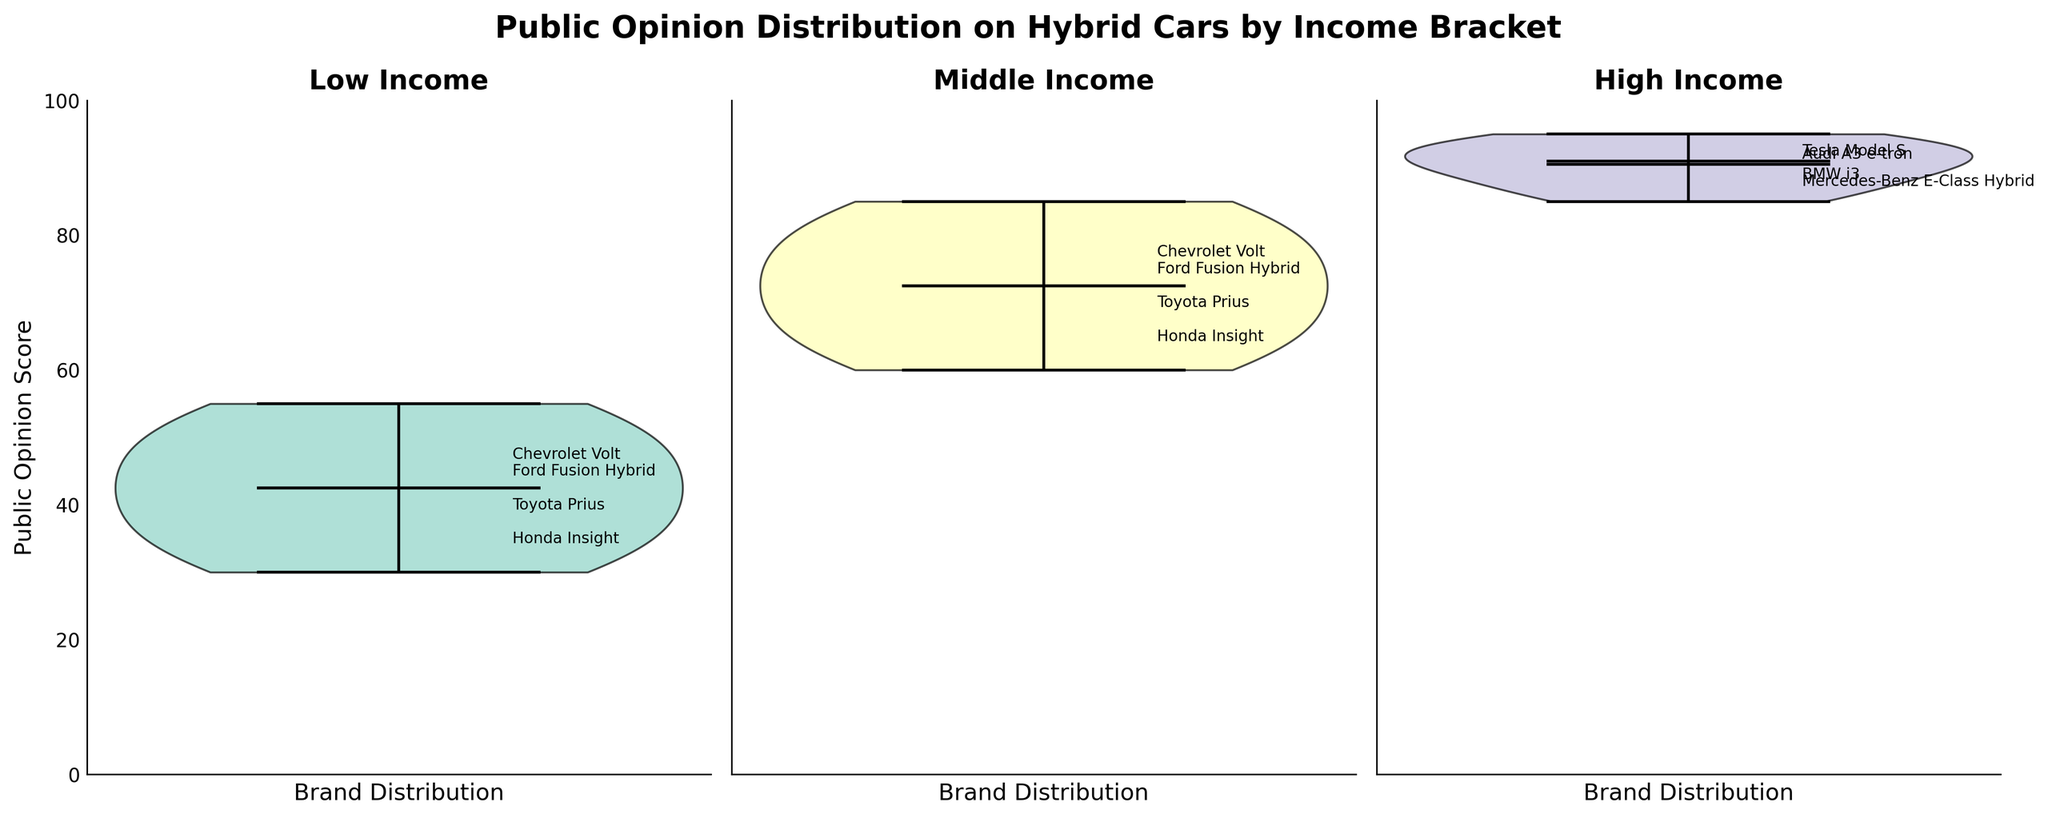What is the title of the figure? The title of the figure is typically found at the top center and succinctly describes the subject of the figure.
Answer: Public Opinion Distribution on Hybrid Cars by Income Bracket How many income brackets are represented in the figure? There are three subplots, each representing a different income bracket.
Answer: Three What is the y-axis label in the figure? The y-axis label provides information about what the y-values represent.
Answer: Public Opinion Score What is the median public opinion score for the low income bracket? The median is the value separating the higher half from the lower half of the data points. It is shown as a horizontal line inside the violin plot.
Answer: 42.5 What is the average public opinion score for the high income bracket? To find the average, sum all the public opinion scores in the high income bracket and divide by the number of data points in that bracket. The scores are 90, 85, 88, 92, 95, and 93. Their sum is 543, and there are six data points, so the average is 543/6 = 90.5.
Answer: 90.5 Which income bracket has the highest mean public opinion score? The mean is shown as a dot within the violin plot. Compare the mean positions across all three subplots.
Answer: High income Which brand appears to have the highest average public opinion score in the middle income bracket? The average positions of brands are indicated by their proximity to labeled points on the violin plot. We need to look at the specific positions labeled near the violins in the middle income bracket subplot.
Answer: Toyota Prius Do any of the income brackets have an outlier in public opinion scores? Outliers are typically marked as individual points outside the main body of the plot.
Answer: No Which income bracket shows the most spread in public opinion scores? The spread is reflected by the width of the violin plot. The wider the distribution, the more spread there is.
Answer: Low income 